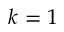Convert formula to latex. <formula><loc_0><loc_0><loc_500><loc_500>k = 1</formula> 